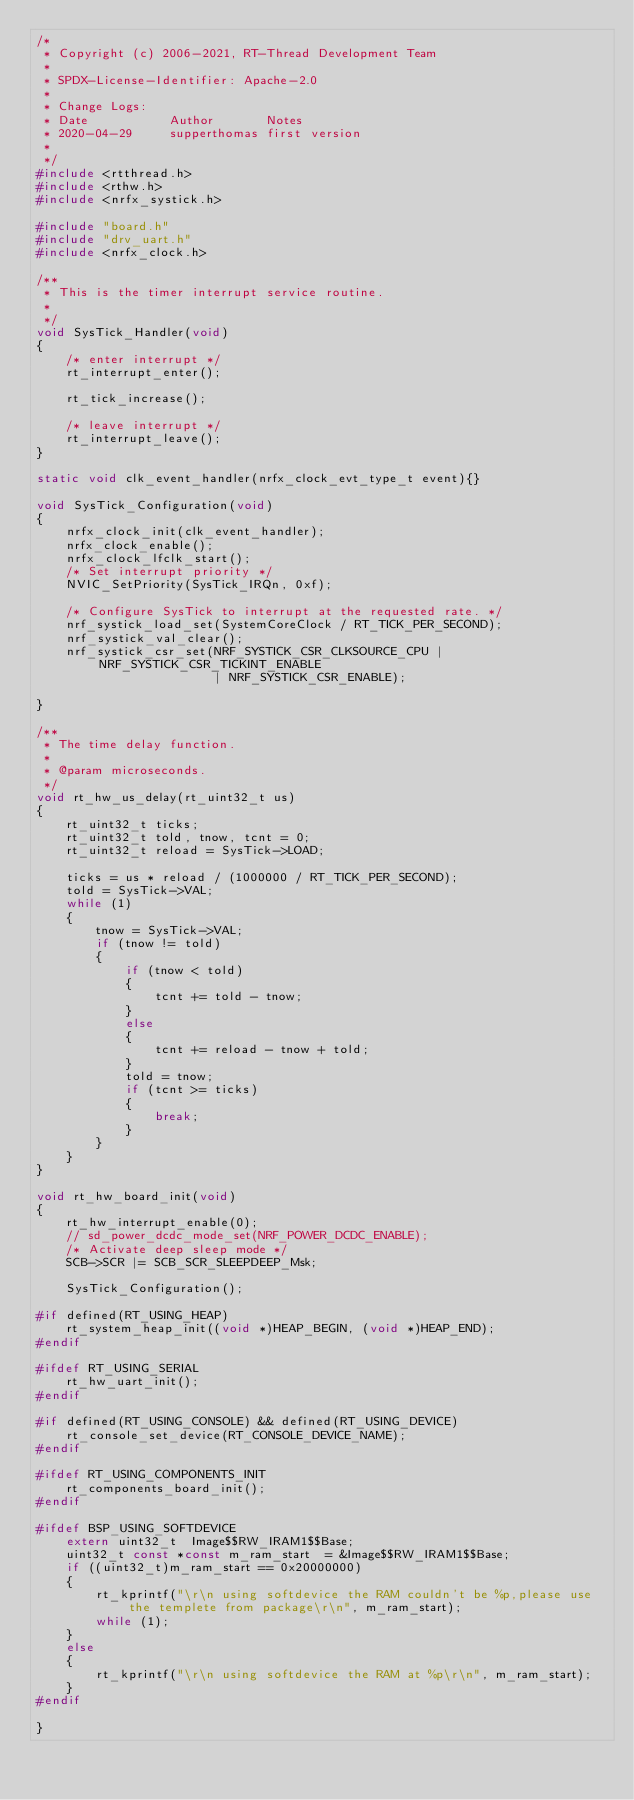Convert code to text. <code><loc_0><loc_0><loc_500><loc_500><_C_>/*
 * Copyright (c) 2006-2021, RT-Thread Development Team
 *
 * SPDX-License-Identifier: Apache-2.0
 *
 * Change Logs:
 * Date           Author       Notes
 * 2020-04-29     supperthomas first version
 *
 */
#include <rtthread.h>
#include <rthw.h>
#include <nrfx_systick.h>

#include "board.h"
#include "drv_uart.h"
#include <nrfx_clock.h>

/**
 * This is the timer interrupt service routine.
 *
 */
void SysTick_Handler(void)
{
    /* enter interrupt */
    rt_interrupt_enter();

    rt_tick_increase();

    /* leave interrupt */
    rt_interrupt_leave();
}

static void clk_event_handler(nrfx_clock_evt_type_t event){}

void SysTick_Configuration(void)
{
    nrfx_clock_init(clk_event_handler);
    nrfx_clock_enable();
    nrfx_clock_lfclk_start();
    /* Set interrupt priority */
    NVIC_SetPriority(SysTick_IRQn, 0xf);

    /* Configure SysTick to interrupt at the requested rate. */
    nrf_systick_load_set(SystemCoreClock / RT_TICK_PER_SECOND);
    nrf_systick_val_clear();
    nrf_systick_csr_set(NRF_SYSTICK_CSR_CLKSOURCE_CPU | NRF_SYSTICK_CSR_TICKINT_ENABLE
                        | NRF_SYSTICK_CSR_ENABLE);

}

/**
 * The time delay function.
 *
 * @param microseconds.
 */
void rt_hw_us_delay(rt_uint32_t us)
{
    rt_uint32_t ticks;
    rt_uint32_t told, tnow, tcnt = 0;
    rt_uint32_t reload = SysTick->LOAD;

    ticks = us * reload / (1000000 / RT_TICK_PER_SECOND);
    told = SysTick->VAL;
    while (1)
    {
        tnow = SysTick->VAL;
        if (tnow != told)
        {
            if (tnow < told)
            {
                tcnt += told - tnow;
            }
            else
            {
                tcnt += reload - tnow + told;
            }
            told = tnow;
            if (tcnt >= ticks)
            {
                break;
            }
        }
    }
}

void rt_hw_board_init(void)
{
    rt_hw_interrupt_enable(0);
    // sd_power_dcdc_mode_set(NRF_POWER_DCDC_ENABLE);
    /* Activate deep sleep mode */
    SCB->SCR |= SCB_SCR_SLEEPDEEP_Msk;

    SysTick_Configuration();

#if defined(RT_USING_HEAP)
    rt_system_heap_init((void *)HEAP_BEGIN, (void *)HEAP_END);
#endif

#ifdef RT_USING_SERIAL
    rt_hw_uart_init();
#endif

#if defined(RT_USING_CONSOLE) && defined(RT_USING_DEVICE)
    rt_console_set_device(RT_CONSOLE_DEVICE_NAME);
#endif

#ifdef RT_USING_COMPONENTS_INIT
    rt_components_board_init();
#endif

#ifdef BSP_USING_SOFTDEVICE
    extern uint32_t  Image$$RW_IRAM1$$Base;
    uint32_t const *const m_ram_start  = &Image$$RW_IRAM1$$Base;
    if ((uint32_t)m_ram_start == 0x20000000)
    {
        rt_kprintf("\r\n using softdevice the RAM couldn't be %p,please use the templete from package\r\n", m_ram_start);
        while (1);
    }
    else
    {
        rt_kprintf("\r\n using softdevice the RAM at %p\r\n", m_ram_start);
    }
#endif

}

</code> 